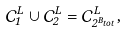<formula> <loc_0><loc_0><loc_500><loc_500>\mathcal { C } ^ { L } _ { 1 } \cup \mathcal { C } ^ { L } _ { 2 } = \mathcal { C } ^ { L } _ { 2 ^ { B _ { t o t } } } ,</formula> 